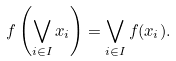<formula> <loc_0><loc_0><loc_500><loc_500>f \left ( \bigvee _ { i \in I } { x _ { i } } \right ) = \bigvee _ { i \in I } f ( x _ { i } ) .</formula> 